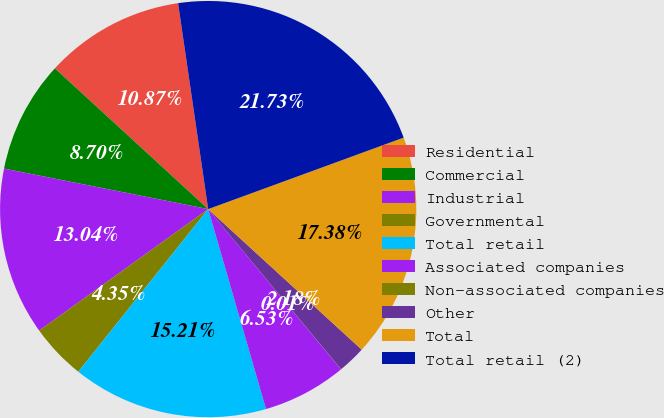Convert chart to OTSL. <chart><loc_0><loc_0><loc_500><loc_500><pie_chart><fcel>Residential<fcel>Commercial<fcel>Industrial<fcel>Governmental<fcel>Total retail<fcel>Associated companies<fcel>Non-associated companies<fcel>Other<fcel>Total<fcel>Total retail (2)<nl><fcel>10.87%<fcel>8.7%<fcel>13.04%<fcel>4.35%<fcel>15.21%<fcel>6.53%<fcel>0.01%<fcel>2.18%<fcel>17.38%<fcel>21.73%<nl></chart> 